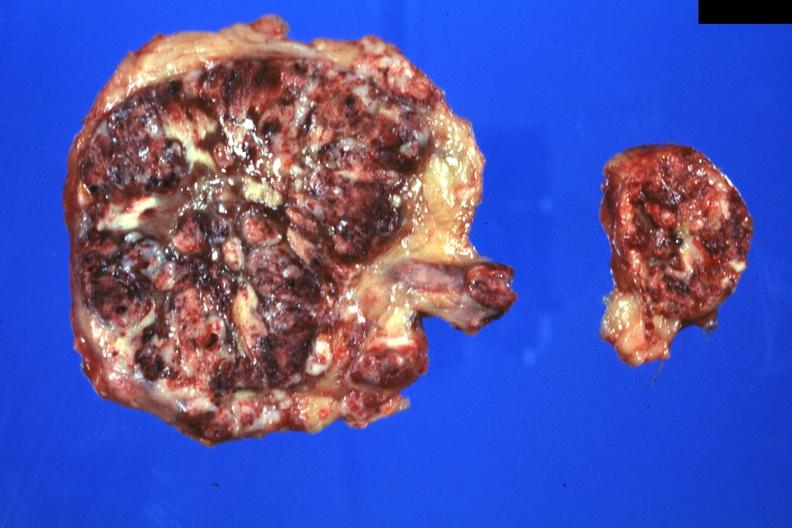does lateral view show massive replacement can not see any adrenal tissue?
Answer the question using a single word or phrase. No 